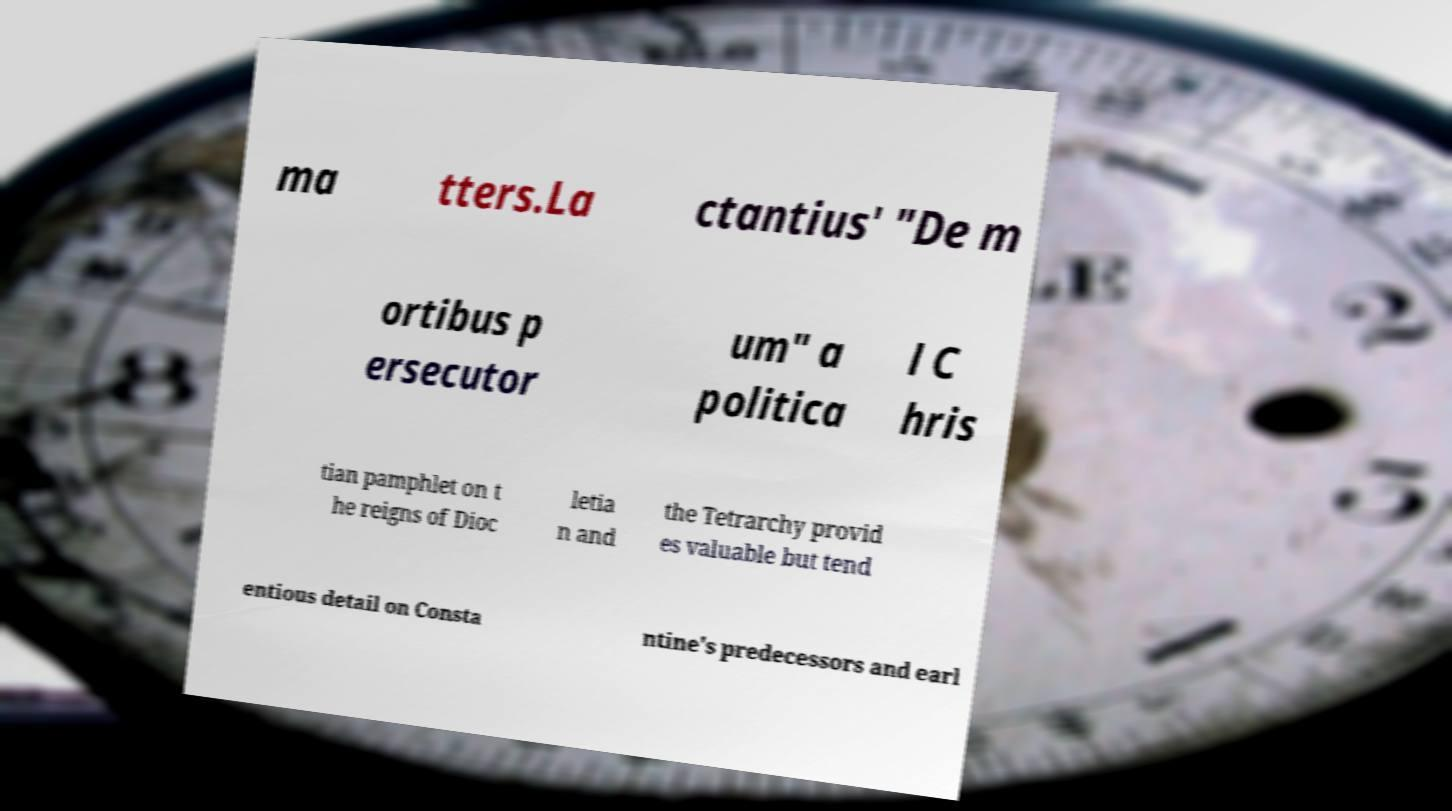Please identify and transcribe the text found in this image. ma tters.La ctantius' "De m ortibus p ersecutor um" a politica l C hris tian pamphlet on t he reigns of Dioc letia n and the Tetrarchy provid es valuable but tend entious detail on Consta ntine's predecessors and earl 